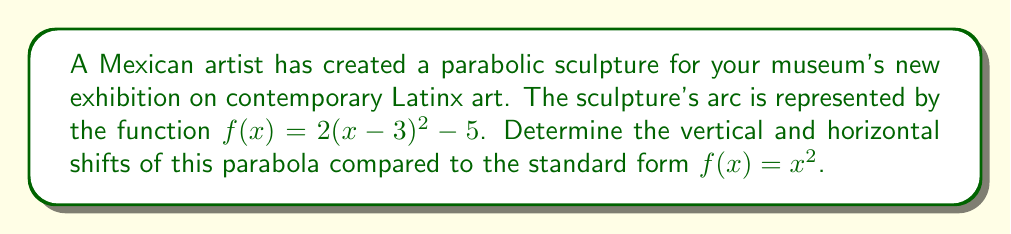Give your solution to this math problem. To determine the vertical and horizontal shifts of the parabola, we need to compare the given function to the standard form of a parabola.

1. Standard form of a parabola: $f(x) = x^2$

2. Given function: $f(x) = 2(x-3)^2 - 5$

3. Let's rewrite the given function in the form $f(x) = a(x-h)^2 + k$, where:
   - $a$ determines the opening of the parabola (not relevant for shifts)
   - $h$ represents the horizontal shift
   - $k$ represents the vertical shift

4. In our case:
   $f(x) = 2(x-3)^2 - 5$
   
   We can identify that:
   - $h = 3$
   - $k = -5$

5. Horizontal shift:
   - The expression $(x-3)$ indicates a shift of 3 units to the right
   - Therefore, the horizontal shift is 3 units to the right

6. Vertical shift:
   - The "-5" at the end of the function indicates a shift of 5 units down
   - Therefore, the vertical shift is 5 units down

Thus, compared to the standard parabola $f(x) = x^2$, this sculpture's parabolic arc is shifted 3 units to the right and 5 units down.
Answer: Horizontal shift: 3 units right
Vertical shift: 5 units down 